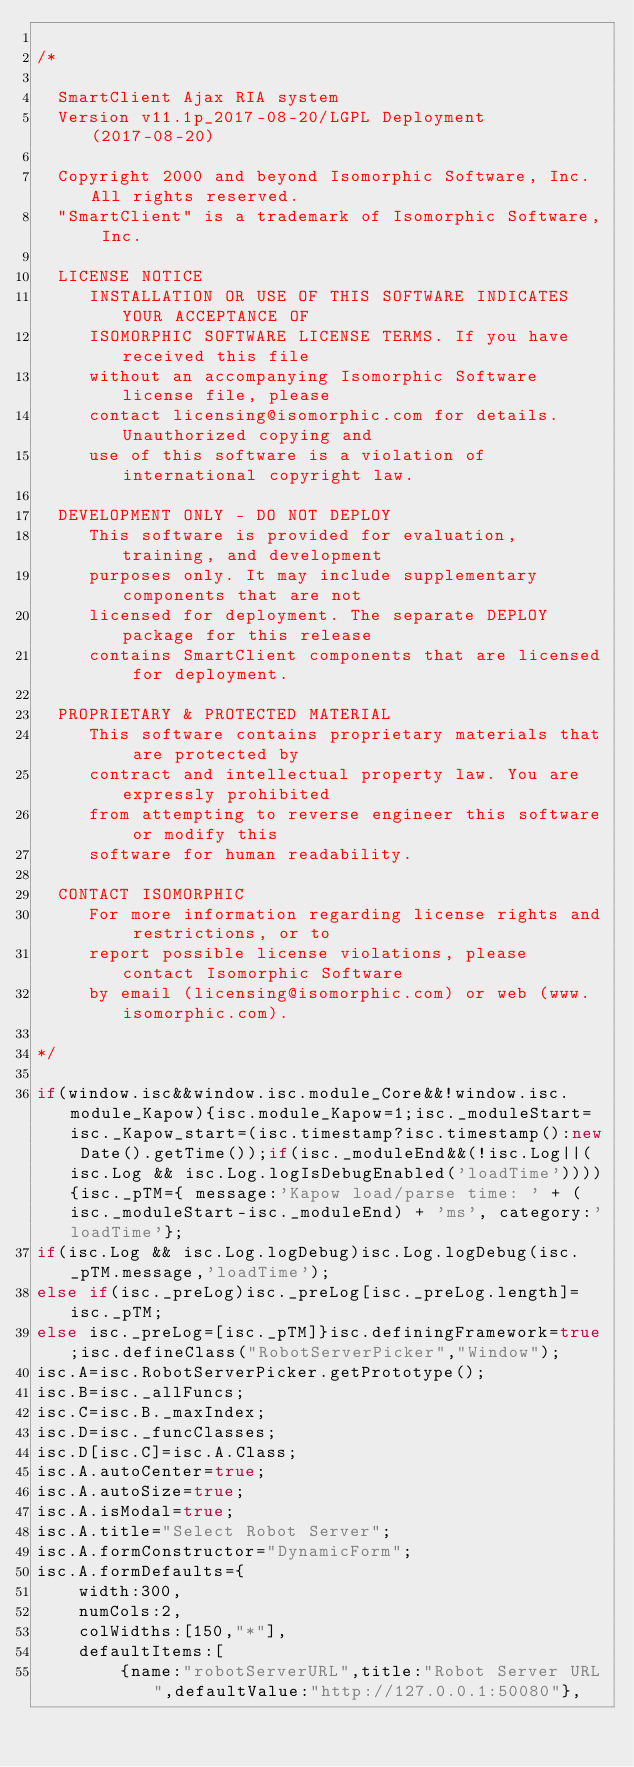Convert code to text. <code><loc_0><loc_0><loc_500><loc_500><_JavaScript_>
/*

  SmartClient Ajax RIA system
  Version v11.1p_2017-08-20/LGPL Deployment (2017-08-20)

  Copyright 2000 and beyond Isomorphic Software, Inc. All rights reserved.
  "SmartClient" is a trademark of Isomorphic Software, Inc.

  LICENSE NOTICE
     INSTALLATION OR USE OF THIS SOFTWARE INDICATES YOUR ACCEPTANCE OF
     ISOMORPHIC SOFTWARE LICENSE TERMS. If you have received this file
     without an accompanying Isomorphic Software license file, please
     contact licensing@isomorphic.com for details. Unauthorized copying and
     use of this software is a violation of international copyright law.

  DEVELOPMENT ONLY - DO NOT DEPLOY
     This software is provided for evaluation, training, and development
     purposes only. It may include supplementary components that are not
     licensed for deployment. The separate DEPLOY package for this release
     contains SmartClient components that are licensed for deployment.

  PROPRIETARY & PROTECTED MATERIAL
     This software contains proprietary materials that are protected by
     contract and intellectual property law. You are expressly prohibited
     from attempting to reverse engineer this software or modify this
     software for human readability.

  CONTACT ISOMORPHIC
     For more information regarding license rights and restrictions, or to
     report possible license violations, please contact Isomorphic Software
     by email (licensing@isomorphic.com) or web (www.isomorphic.com).

*/

if(window.isc&&window.isc.module_Core&&!window.isc.module_Kapow){isc.module_Kapow=1;isc._moduleStart=isc._Kapow_start=(isc.timestamp?isc.timestamp():new Date().getTime());if(isc._moduleEnd&&(!isc.Log||(isc.Log && isc.Log.logIsDebugEnabled('loadTime')))){isc._pTM={ message:'Kapow load/parse time: ' + (isc._moduleStart-isc._moduleEnd) + 'ms', category:'loadTime'};
if(isc.Log && isc.Log.logDebug)isc.Log.logDebug(isc._pTM.message,'loadTime');
else if(isc._preLog)isc._preLog[isc._preLog.length]=isc._pTM;
else isc._preLog=[isc._pTM]}isc.definingFramework=true;isc.defineClass("RobotServerPicker","Window");
isc.A=isc.RobotServerPicker.getPrototype();
isc.B=isc._allFuncs;
isc.C=isc.B._maxIndex;
isc.D=isc._funcClasses;
isc.D[isc.C]=isc.A.Class;
isc.A.autoCenter=true;
isc.A.autoSize=true;
isc.A.isModal=true;
isc.A.title="Select Robot Server";
isc.A.formConstructor="DynamicForm";
isc.A.formDefaults={
    width:300,
    numCols:2,
    colWidths:[150,"*"],
    defaultItems:[
        {name:"robotServerURL",title:"Robot Server URL",defaultValue:"http://127.0.0.1:50080"},</code> 